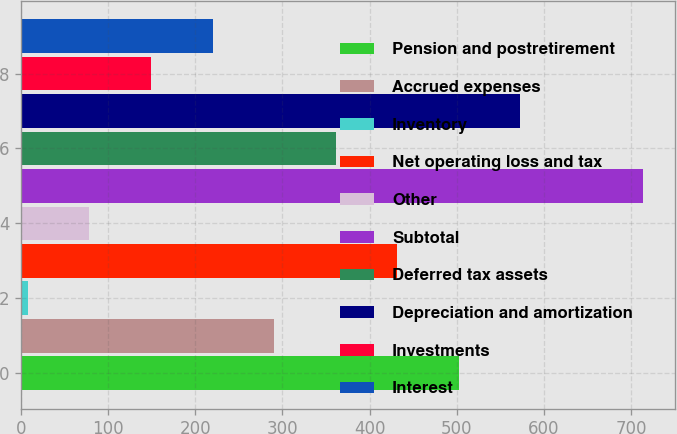Convert chart to OTSL. <chart><loc_0><loc_0><loc_500><loc_500><bar_chart><fcel>Pension and postretirement<fcel>Accrued expenses<fcel>Inventory<fcel>Net operating loss and tax<fcel>Other<fcel>Subtotal<fcel>Deferred tax assets<fcel>Depreciation and amortization<fcel>Investments<fcel>Interest<nl><fcel>502.2<fcel>290.4<fcel>8<fcel>431.6<fcel>78.6<fcel>714<fcel>361<fcel>572.8<fcel>149.2<fcel>219.8<nl></chart> 